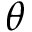Convert formula to latex. <formula><loc_0><loc_0><loc_500><loc_500>\theta</formula> 